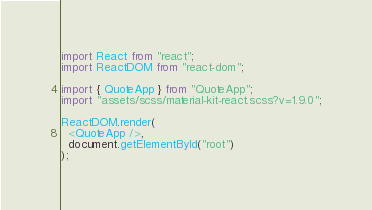<code> <loc_0><loc_0><loc_500><loc_500><_JavaScript_>import React from "react";
import ReactDOM from "react-dom";

import { QuoteApp } from "QuoteApp";
import "assets/scss/material-kit-react.scss?v=1.9.0";

ReactDOM.render(
  <QuoteApp />,
  document.getElementById("root")
);
</code> 